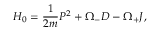Convert formula to latex. <formula><loc_0><loc_0><loc_500><loc_500>H _ { 0 } = \frac { 1 } { 2 m } P ^ { 2 } + \Omega _ { - } D - \Omega _ { + } J ,</formula> 